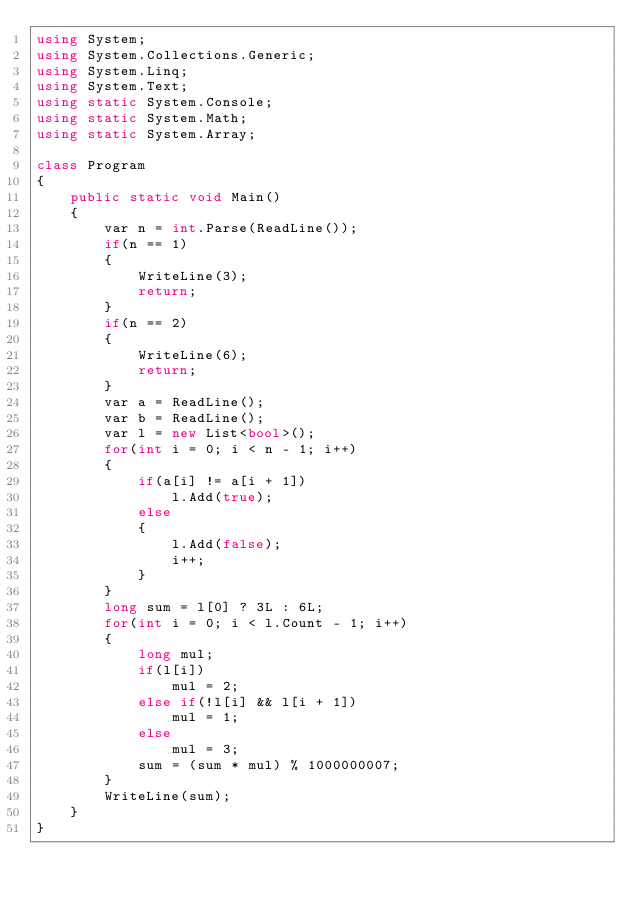<code> <loc_0><loc_0><loc_500><loc_500><_C#_>using System;
using System.Collections.Generic;
using System.Linq;
using System.Text;
using static System.Console;
using static System.Math;
using static System.Array;

class Program
{
	public static void Main()
	{
		var n = int.Parse(ReadLine());
		if(n == 1)
		{
			WriteLine(3);
			return;
		}
		if(n == 2)
		{
			WriteLine(6);
			return;
		}
		var a = ReadLine();
		var b = ReadLine();
		var l = new List<bool>();
		for(int i = 0; i < n - 1; i++)
		{
			if(a[i] != a[i + 1])
				l.Add(true);
			else
			{
				l.Add(false);
				i++;
			}
		}
		long sum = l[0] ? 3L : 6L;
		for(int i = 0; i < l.Count - 1; i++)
		{
			long mul;
			if(l[i])
				mul = 2;
			else if(!l[i] && l[i + 1])
				mul = 1;
			else
				mul = 3;
			sum = (sum * mul) % 1000000007;
		}
		WriteLine(sum);
	}
}
</code> 